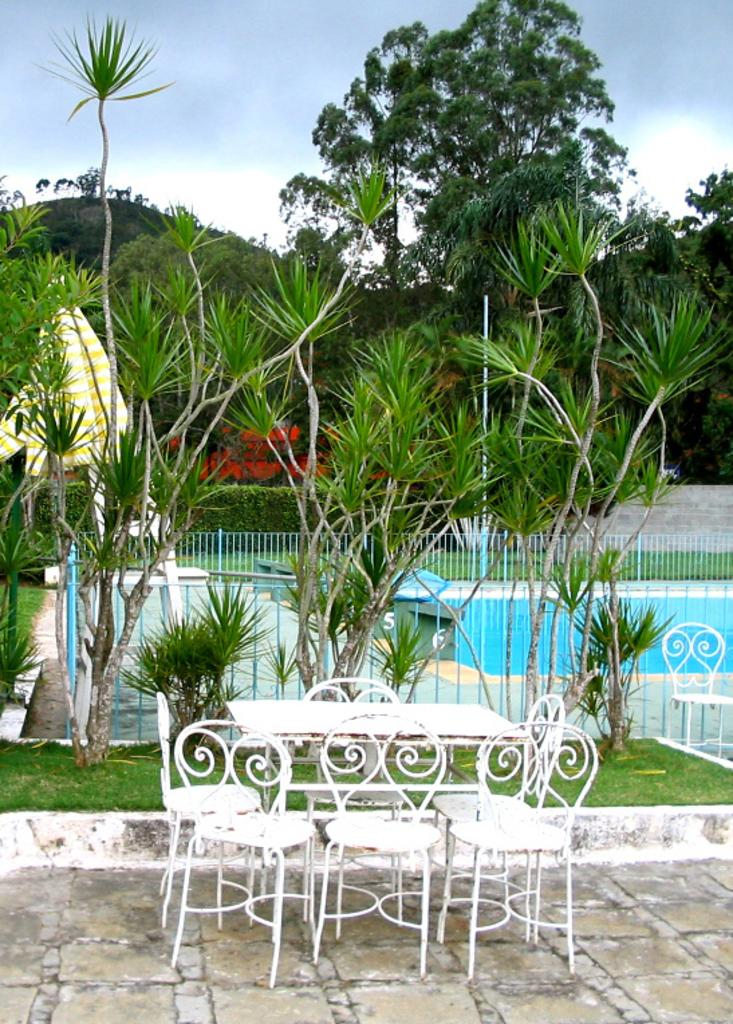What type of furniture is present in the image? There is a table and chairs in the image. What can be seen in the background of the image? Trees and a fence are present in the image. What is visible at the top of the image? The sky is visible at the top of the image. What type of secretary is sitting behind the table in the image? There is no secretary present in the image. What is the alarm used for in the image? There is no alarm present in the image. 